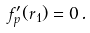<formula> <loc_0><loc_0><loc_500><loc_500>f _ { p } ^ { \prime } ( r _ { 1 } ) = 0 \, .</formula> 